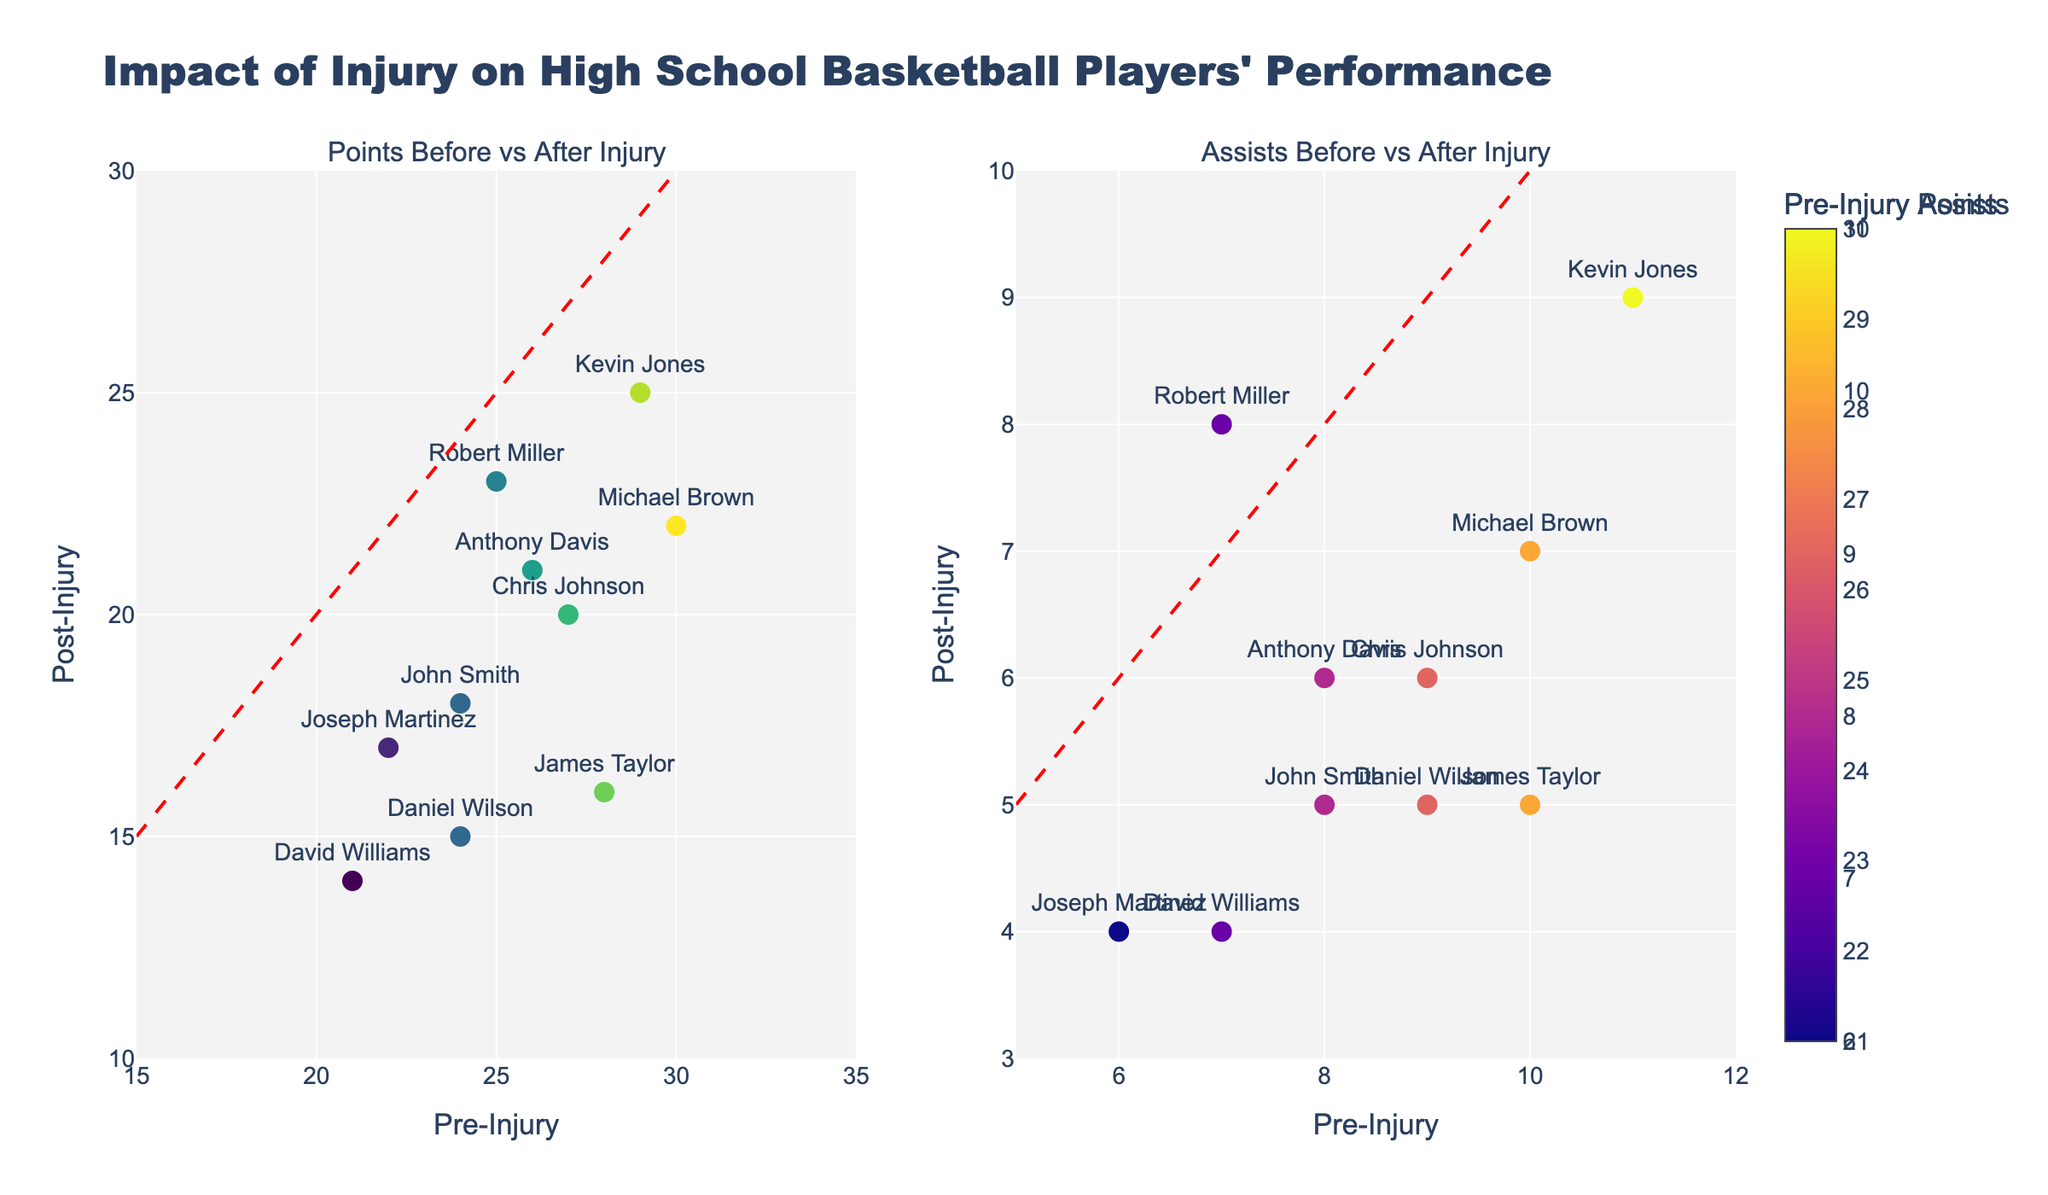What is the title of the figure? The title is located at the top center of the figure, it reads "Impact of Injury on High School Basketball Players' Performance"
Answer: Impact of Injury on High School Basketball Players' Performance How many subplots are there in the figure? There are two distinct visual sections within the figure, each representing a different aspect of player performance before and after injury. These two sections are identified as subplots.
Answer: 2 What is the color of the diagonal lines in both subplots? The diagonal lines are intended to represent the line of equality in each subplot and are drawn with a consistent style across the figure. The lines are colored red.
Answer: Red How many players have their Pre-Injury Assists equal to or greater than their Post-Injury Assists? To answer this, check each player's Pre-Injury and Post-Injury Assists. If the Pre-Injury value is equal to or greater than the Post-Injury value, count that player. Players that meet the criteria include John Smith, Michael Brown, Chris Johnson, David Williams, James Taylor, Joseph Martinez, Anthony Davis, and Daniel Wilson, totaling 8 players.
Answer: 8 Which player has the highest Pre-Injury Points? To determine the highest Pre-Injury Points, compare the Pre-Injury Points column for each player. Michael Brown has the highest value at 30 points.
Answer: Michael Brown How much did David Williams' assists change after the injury? Subtract David Williams' Post-Injury Assists (4) from his Pre-Injury Assists (7). The change is 7 - 4 = 3 assists.
Answer: 3 Are there any players who improved their points after injury? By comparing Pre-Injury and Post-Injury Points for each player, Robert Miller maintained the closest improvement with Post-Injury Points (23) being close to Pre-Injury Points (25). However, his points did not increase. Thus, there are no players who improved their points post-injury.
Answer: No What is the range of Post-Injury Points across all players? The range is found by subtracting the minimum Post-Injury Points (14 by David Williams) from the maximum Post-Injury Points (25 by Kevin Jones). The range is 25 - 14 = 11 points.
Answer: 11 Which subplot contains the player with the lowest post-injury performance? The subplot with the player name close to the lowest point on the y-axis in the Points subplot shows that David Williams has the lowest post-injury points. Therefore, the "Points Before vs After Injury" subplot contains this data.
Answer: Points Before vs After Injury 